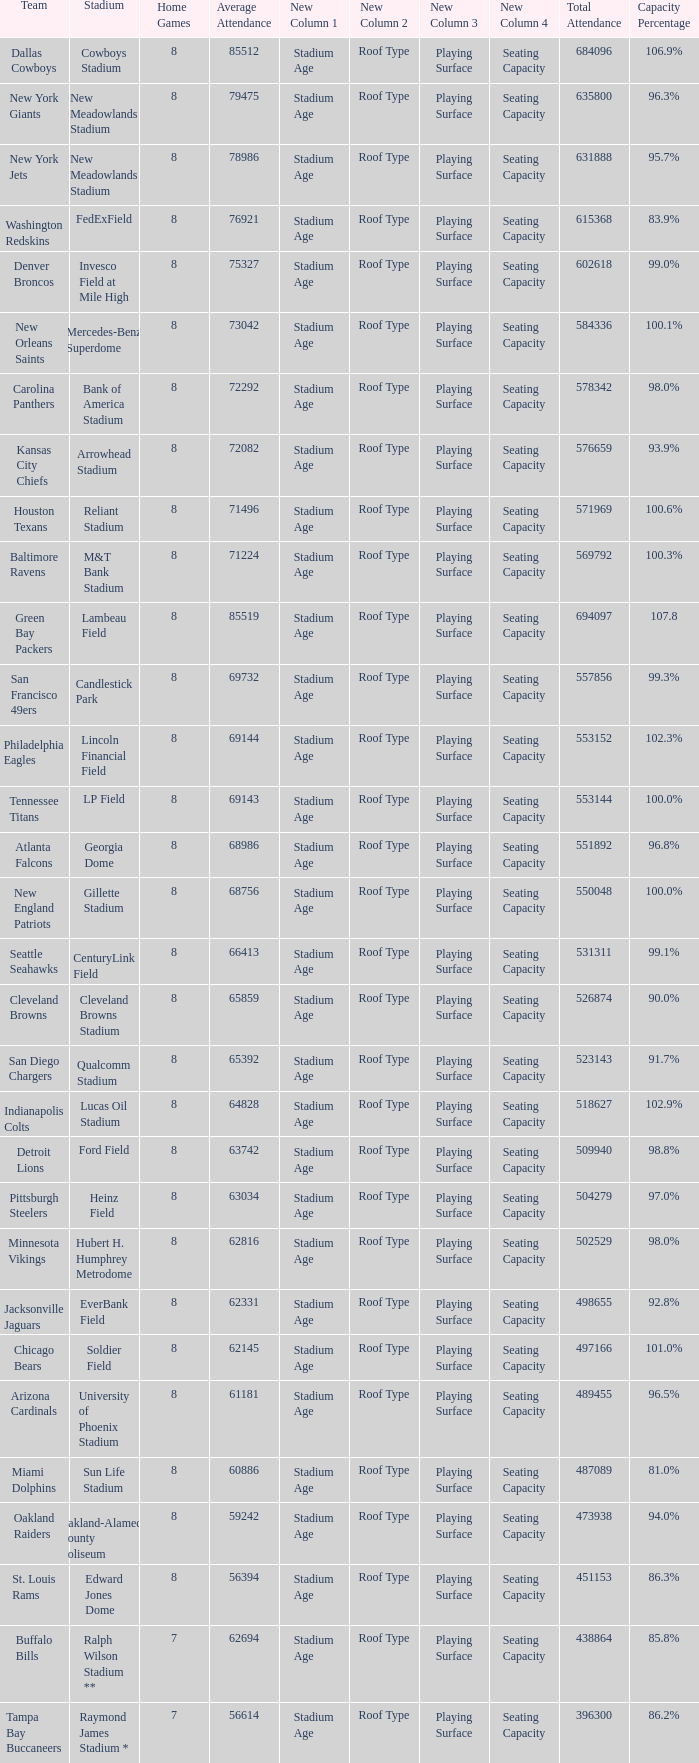What is the capacity percentage when the total attendance is 509940? 98.8%. 